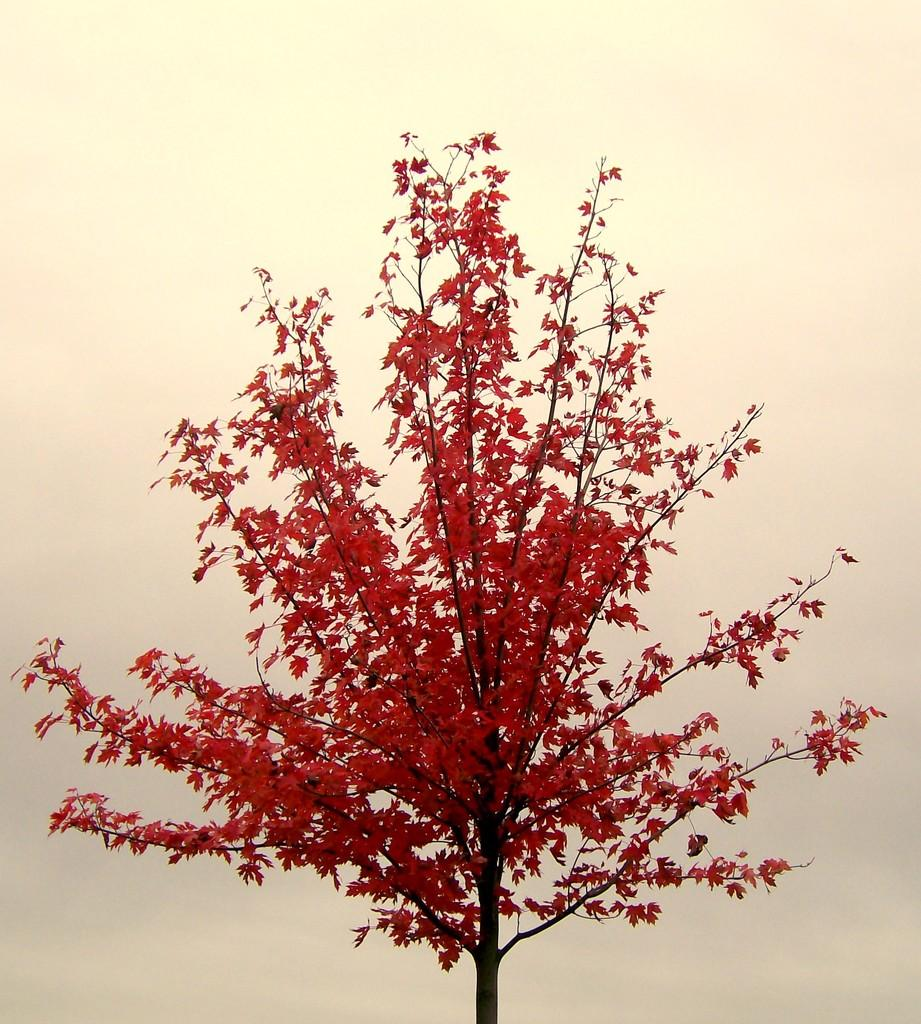What is the main subject of the picture? The main subject of the picture is a tree. What is unique about the tree's appearance? The tree has red-colored leaves. What color is the background of the image? The background of the image is in cream color. How many friends are sitting under the tree in the image? There are no friends present in the image; it only features a tree with red-colored leaves against a cream-colored background. 